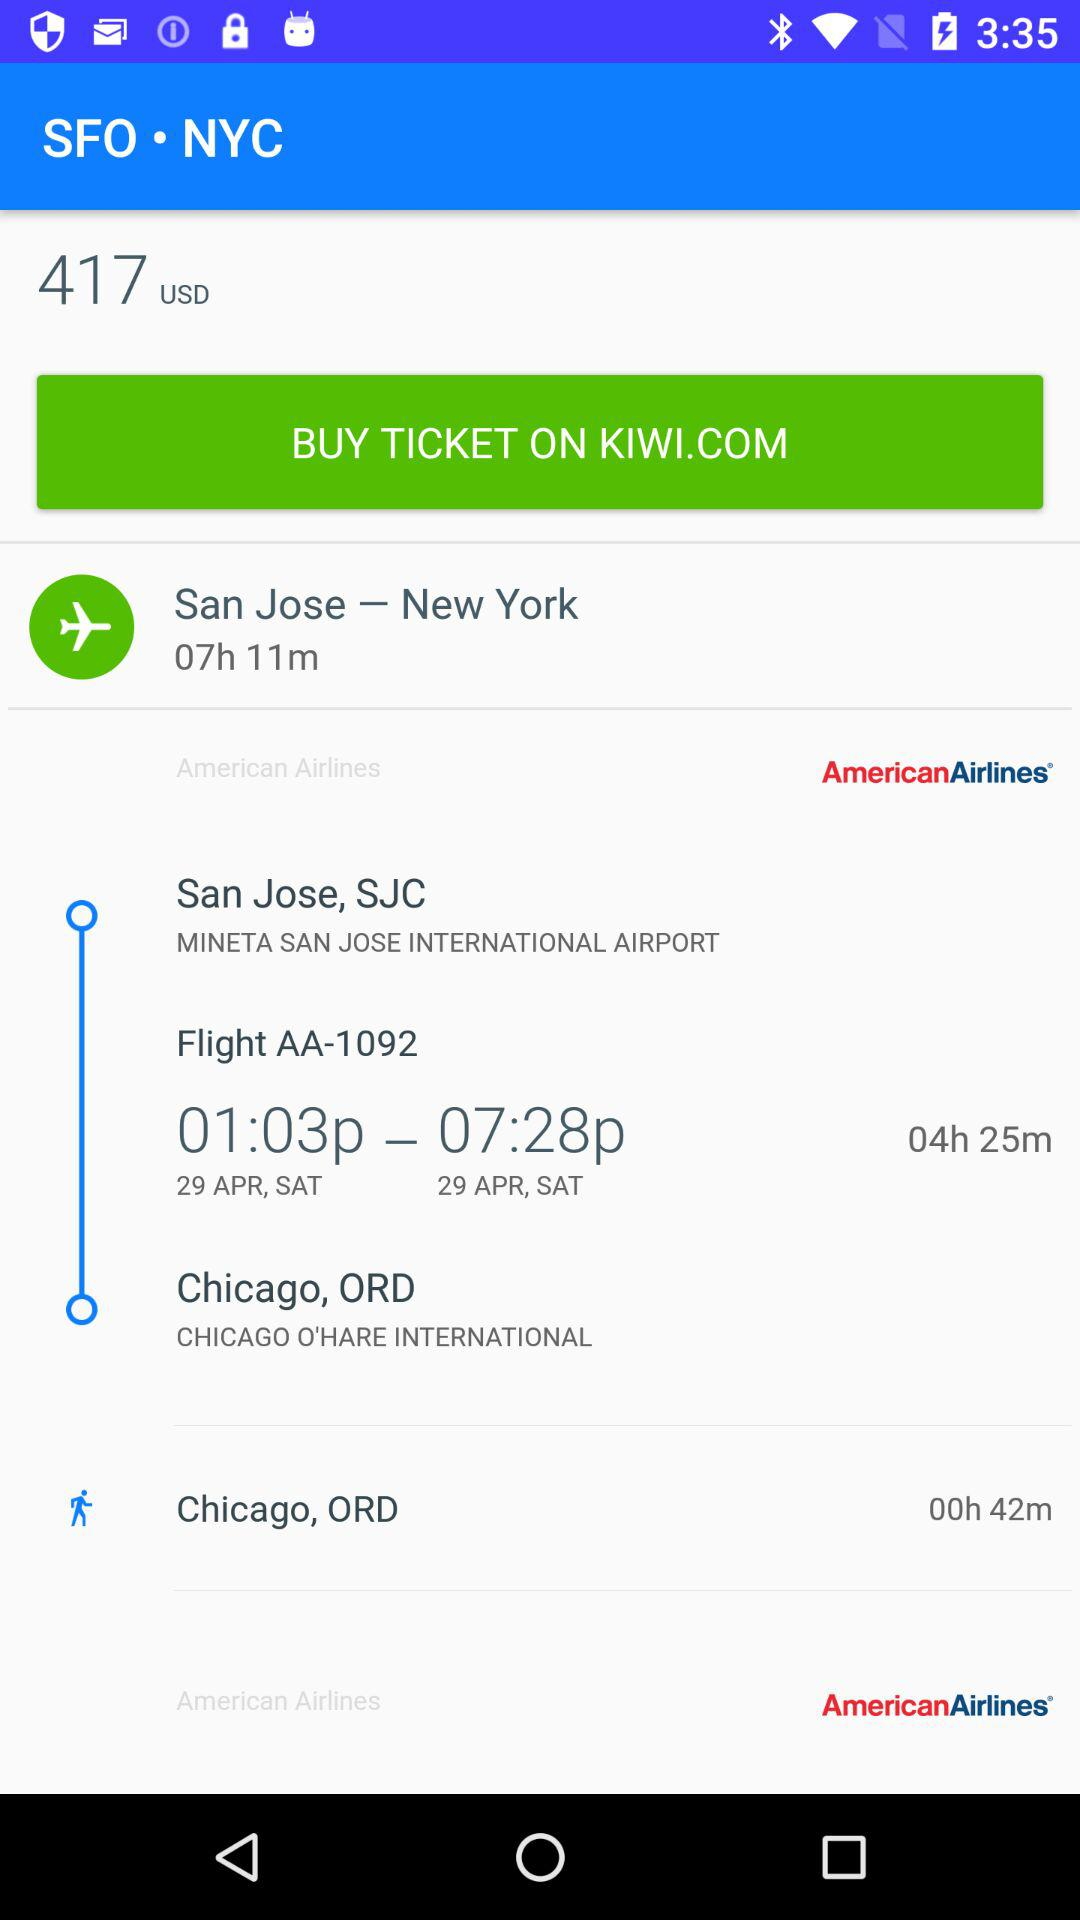How long is the layover in Chicago?
Answer the question using a single word or phrase. 0h 42m 